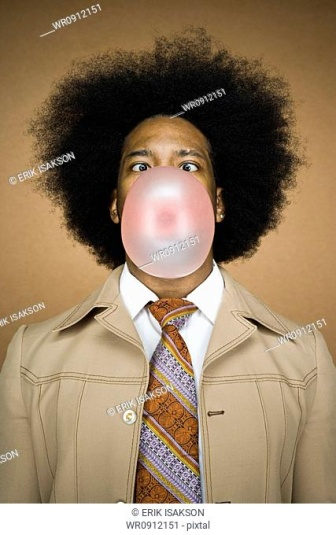Analyze the image in a comprehensive and detailed manner. The image features a person with an impressive, voluminous afro hairstyle prominently displayed in the center. They are blowing a large, pink bubble from bubble gum, which has expanded to cover most of their lower face, including their mouth and nose. The individual is dressed in a tan jacket, offering a formal yet vintage vibe, and they are also wearing a tie adorned with an eye-catching pattern in shades of purple and orange. This tie adds a lively contrast against their tan jacket. The background is a solid orange color, which accentuates the focus on the person in the image. The portrait is well-composed with the person centered, creating a visually balanced and engaging image. There's a playful and stylish essence to the scene, blending retro fashion elements with a light-hearted moment captured perfectly in the photograph. 